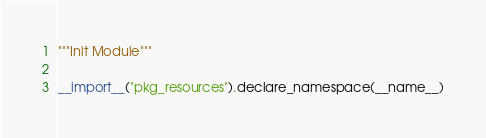Convert code to text. <code><loc_0><loc_0><loc_500><loc_500><_Python_>"""Init Module"""

__import__("pkg_resources").declare_namespace(__name__)
</code> 